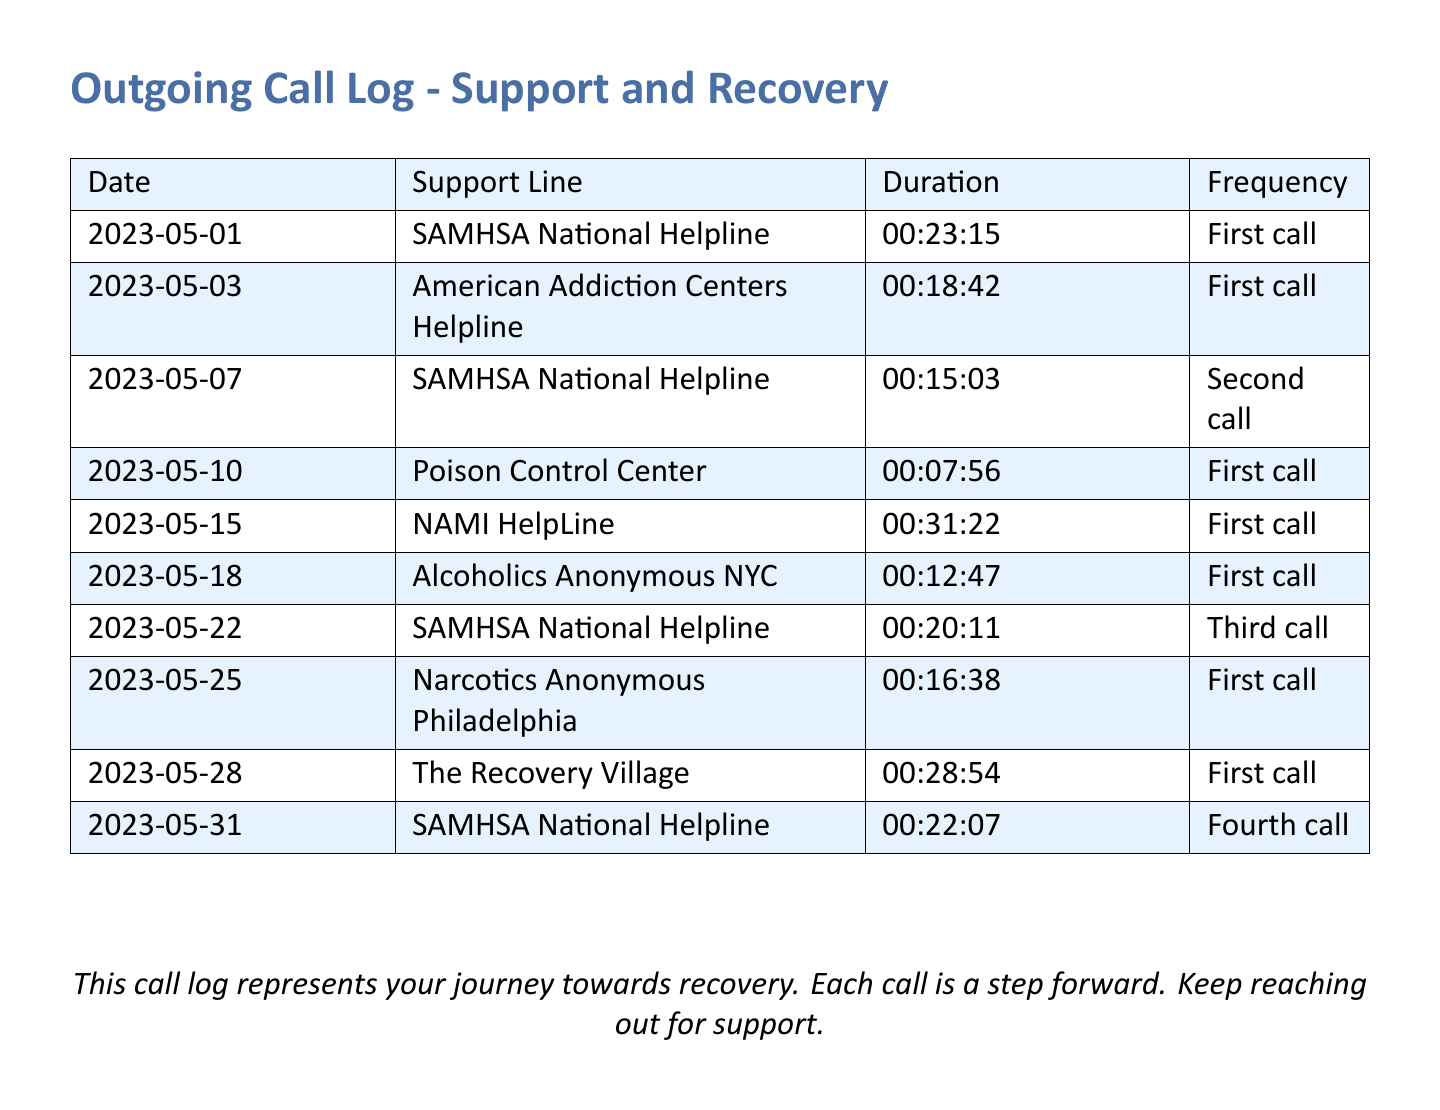what is the duration of the first call to SAMHSA National Helpline? The duration of the first call on 2023-05-01 to SAMHSA National Helpline is indicated in the table.
Answer: 00:23:15 how many times was the SAMHSA National Helpline called? The document shows multiple calls to the same helpline, which can be counted from the frequency column.
Answer: Four calls what is the date of the first call to NAMI HelpLine? The date of the first call to NAMI HelpLine can be found in the table next to the support line name.
Answer: 2023-05-15 what was the duration of the call to The Recovery Village? The duration for the call to The Recovery Village is listed next to its name in the document.
Answer: 00:28:54 which support line was called on May 25, 2023? By checking the listed dates in the document, the support line can be identified for that date.
Answer: Narcotics Anonymous Philadelphia how long was the call to the Poison Control Center? The duration for the call made to the Poison Control Center is specified in the document, which needs to be retrieved.
Answer: 00:07:56 which support line received a call with the longest duration? This requires comparing the durations of all calls to determine which one is the longest.
Answer: NAMI HelpLine how many support lines were contacted for the first time? The number of unique first calls among the support lines can be counted from the frequency column that indicates the call status.
Answer: Six support lines 